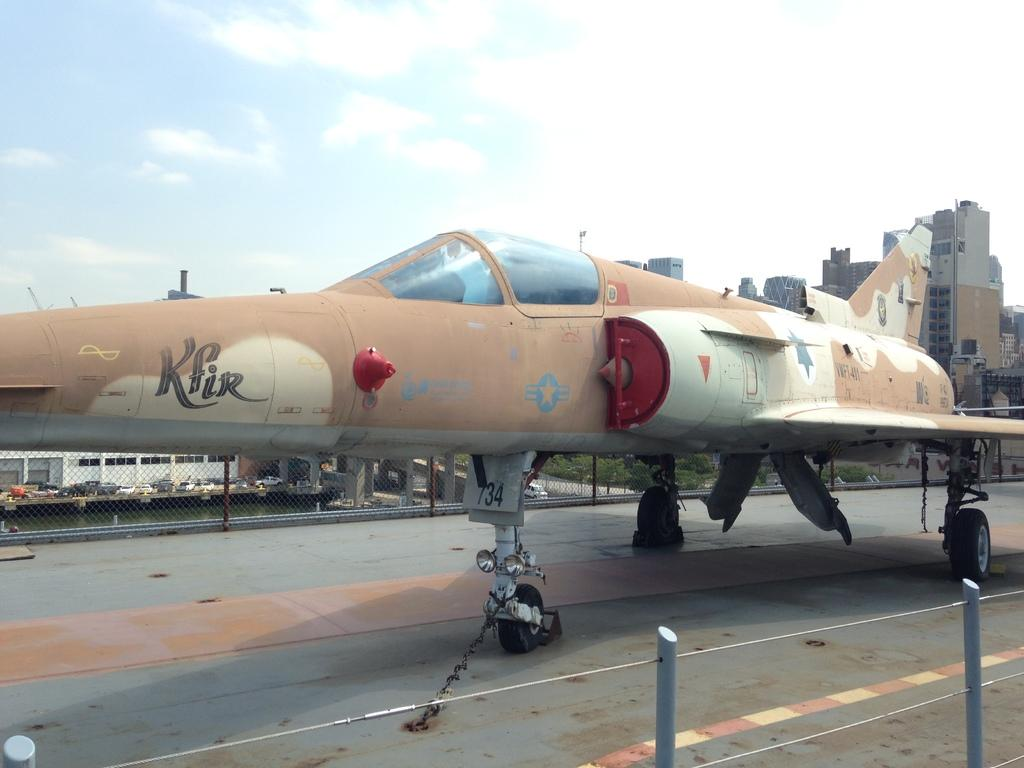<image>
Relay a brief, clear account of the picture shown. An airplane that's currently parked on the runway has the word Kfir painted on its side. 